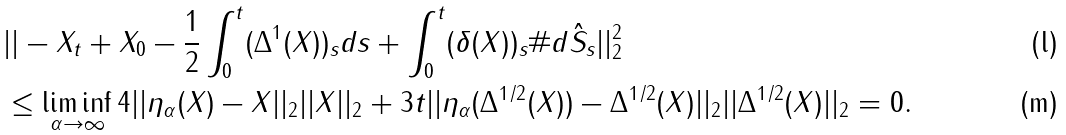<formula> <loc_0><loc_0><loc_500><loc_500>& | | - X _ { t } + X _ { 0 } - \frac { 1 } { 2 } \int _ { 0 } ^ { t } ( \Delta ^ { 1 } ( X ) ) _ { s } d s + \int _ { 0 } ^ { t } ( \delta ( X ) ) _ { s } \# d \hat { S } _ { s } | | _ { 2 } ^ { 2 } \\ & \leq \liminf _ { \alpha \to \infty } 4 | | \eta _ { \alpha } ( X ) - X | | _ { 2 } | | X | | _ { 2 } + 3 t | | \eta _ { \alpha } ( \Delta ^ { 1 / 2 } ( X ) ) - \Delta ^ { 1 / 2 } ( X ) | | _ { 2 } | | \Delta ^ { 1 / 2 } ( X ) | | _ { 2 } = 0 .</formula> 